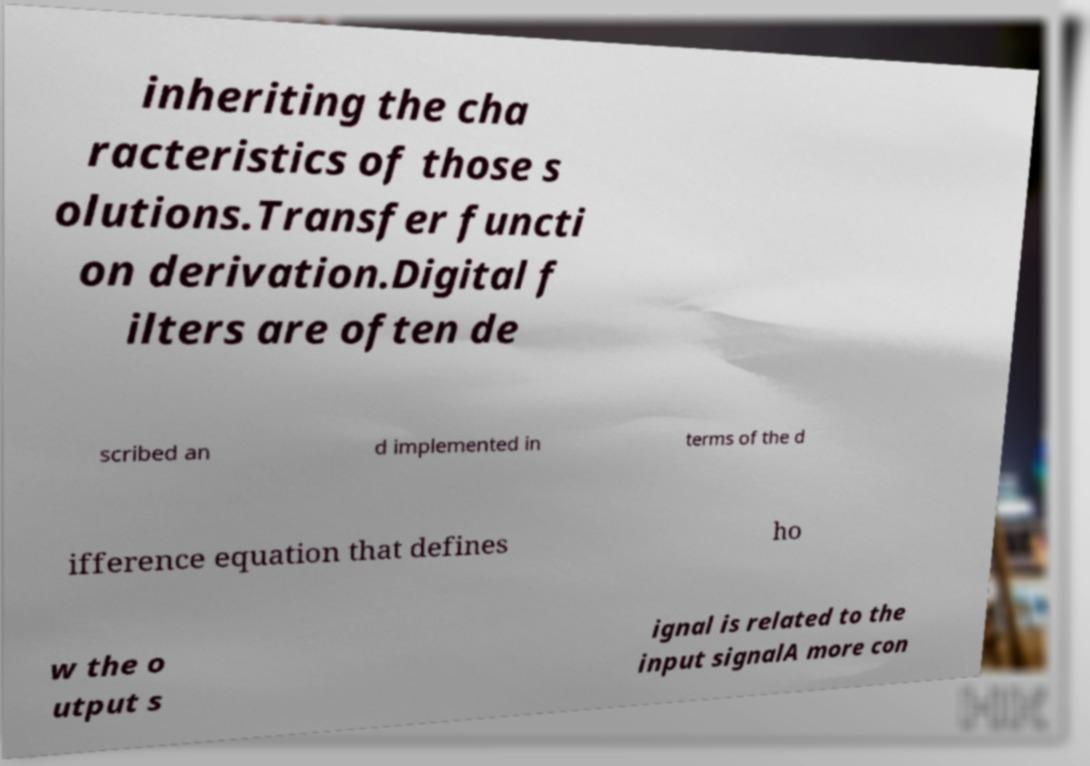Can you accurately transcribe the text from the provided image for me? inheriting the cha racteristics of those s olutions.Transfer functi on derivation.Digital f ilters are often de scribed an d implemented in terms of the d ifference equation that defines ho w the o utput s ignal is related to the input signalA more con 